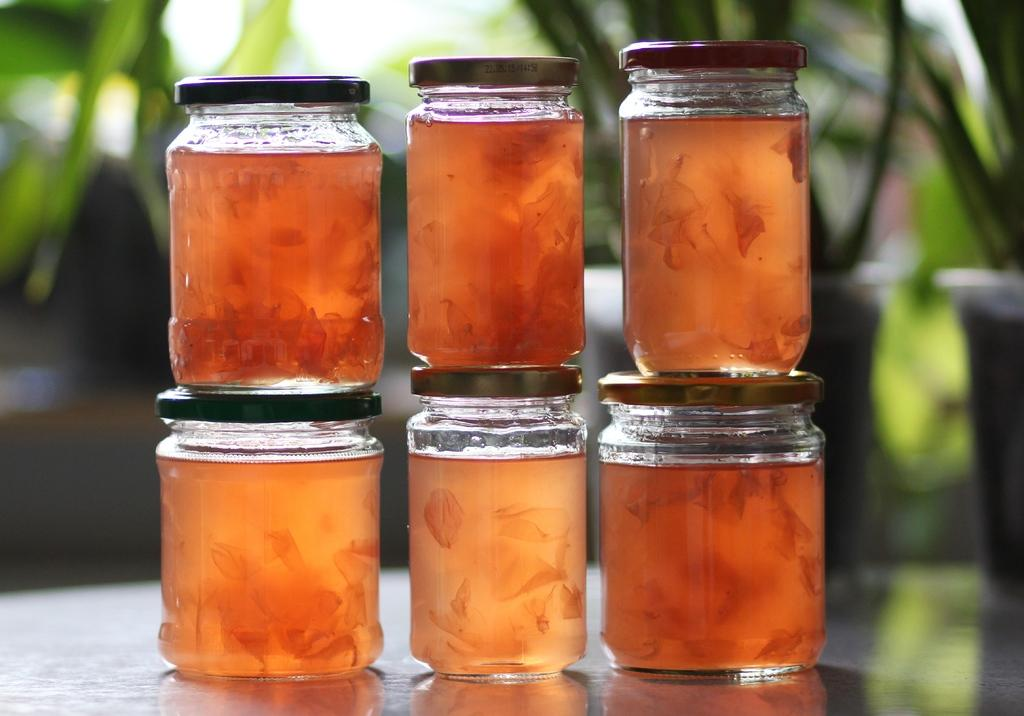How many jars are visible in the image? There are six jars in the image. What is the main focus of the image? The jars are highlighted in the image. How many donkeys are visible in the image? There are no donkeys present in the image. What type of cork is used to seal the jars in the image? The image does not provide information about the type of cork used to seal the jars, if any. 